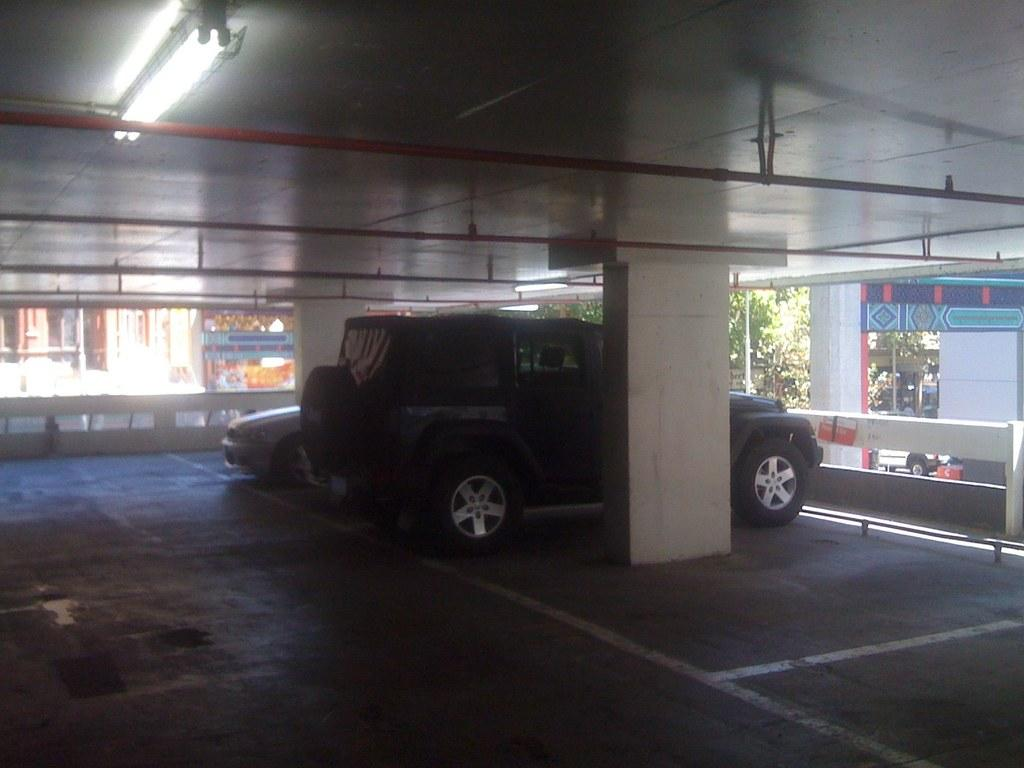What can be seen in the foreground of the image? There are vehicles and a pillar in the foreground of the image. What is visible in the background of the image? There are buildings, trees, and a poster in the background of the image. Can you describe the light in the image? There is a light at the top side of the image. What type of noise can be heard coming from the poster in the image? There is no indication of any noise in the image, and the poster does not appear to be a source of sound. Can you describe the tongue of the tree in the image? There is no tongue present in the image, as trees do not have tongues. 